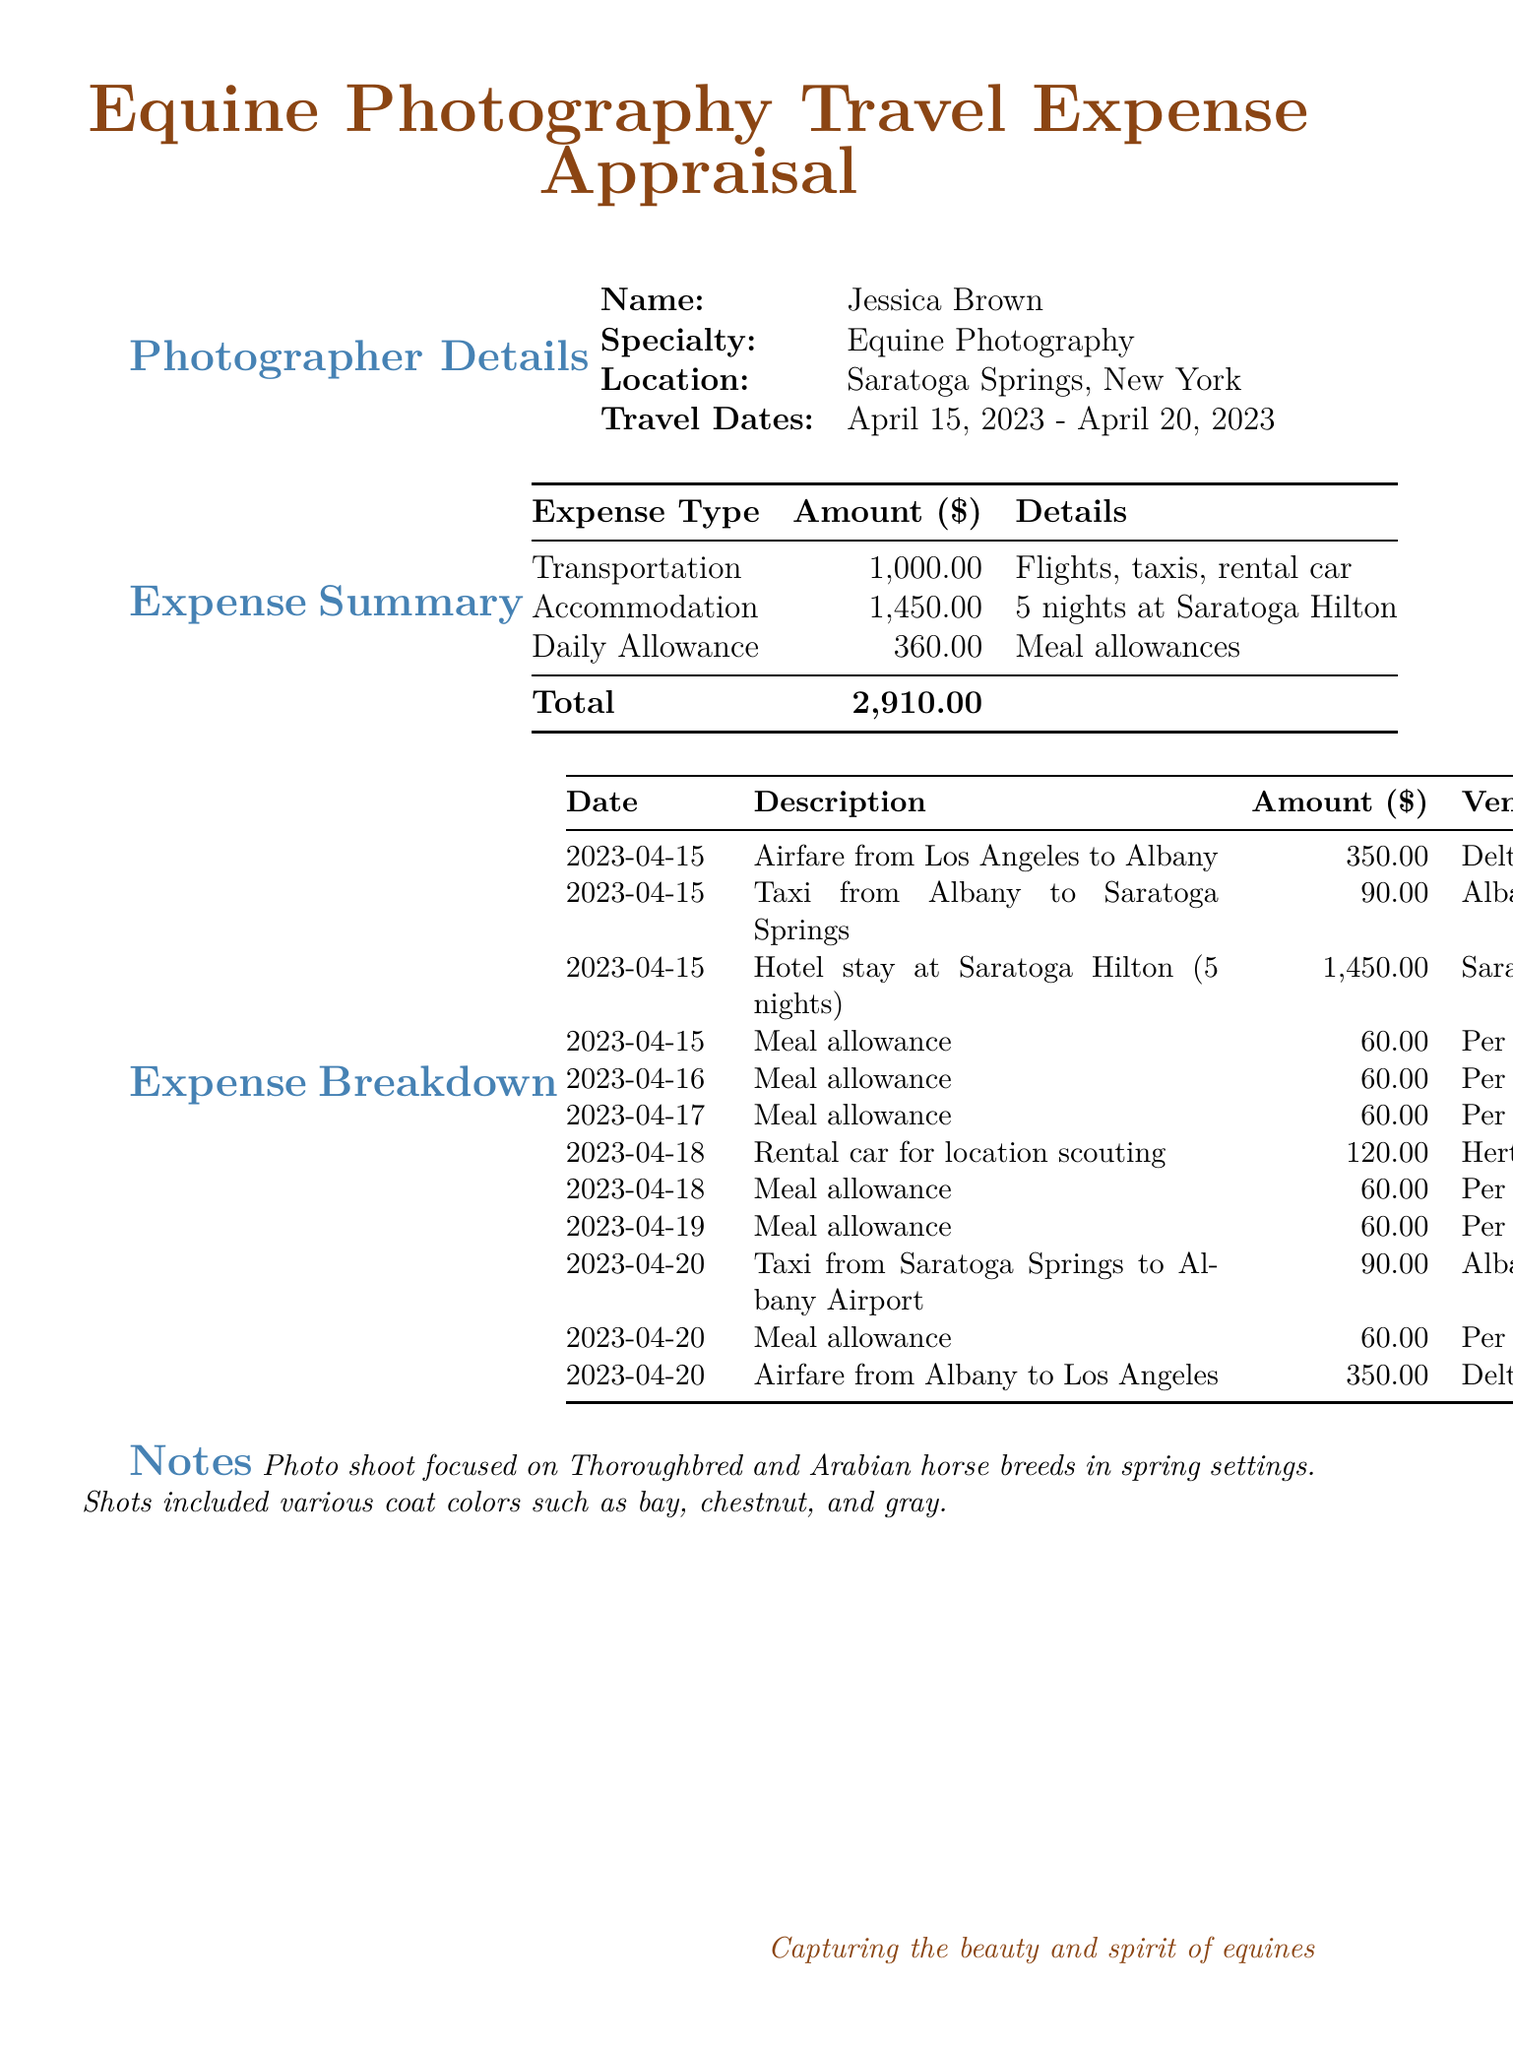what is the total amount of expenses? The total amount of expenses is listed at the bottom of the Expense Summary section.
Answer: 2,910.00 who is the photographer? The photographer's name is provided at the top of the document in the Photographer Details section.
Answer: Jessica Brown what is the providing company for the rental car? The vendor for the rental car is specified in the Expense Breakdown section.
Answer: Hertz Rent a Car how many nights did the photographer stay in the hotel? The number of nights of hotel accommodation is detailed in the Accommodation line of the Expense Summary.
Answer: 5 nights what are the travel dates? The travel dates are listed under the Photographer Details section.
Answer: April 15, 2023 - April 20, 2023 which horse breed was focused on during the photo shoot? The primary focus of the photo shoot is mentioned in the Notes section.
Answer: Thoroughbred and Arabian how much was spent on daily allowances? The daily allowance total is shown in the Expense Summary section.
Answer: 360.00 what was the amount for airfare from Albany to Los Angeles? The specific airfare amount is recorded in the Expense Breakdown section.
Answer: 350.00 what color coat types were captured in the photo shoot? The coat colors captured during the shoot are noted in the Notes section.
Answer: bay, chestnut, and gray 